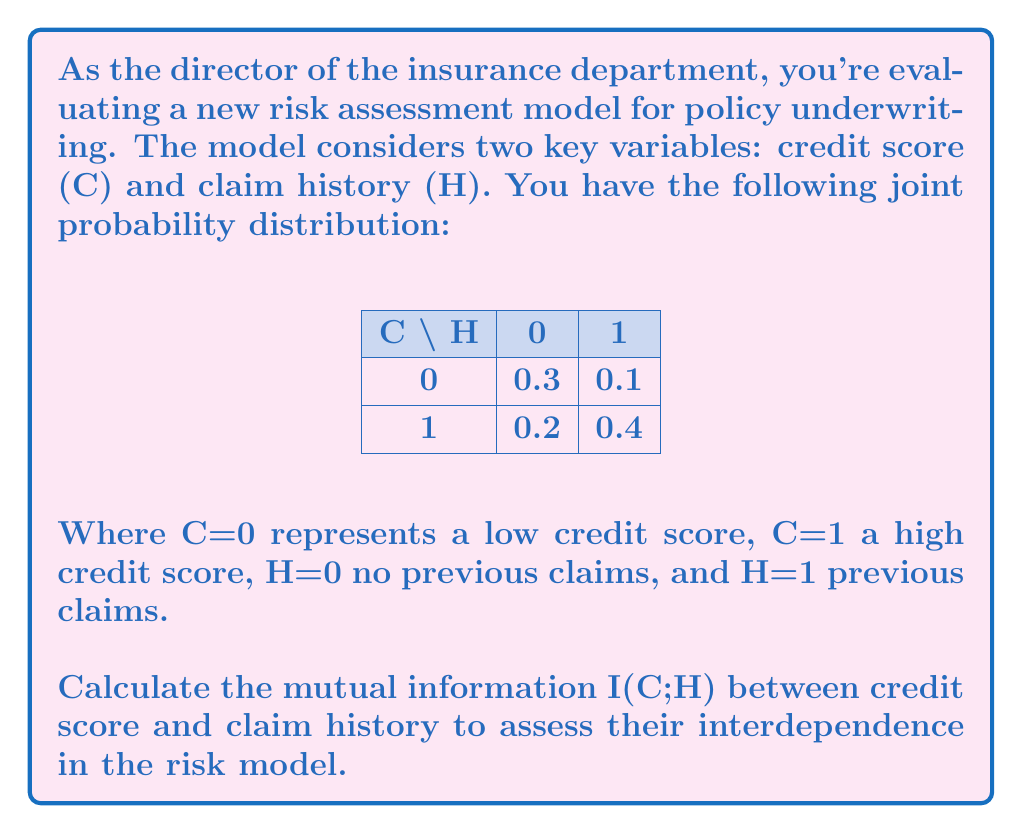Provide a solution to this math problem. To calculate the mutual information I(C;H), we'll follow these steps:

1) First, calculate the marginal probabilities:
   P(C=0) = 0.3 + 0.1 = 0.4
   P(C=1) = 0.2 + 0.4 = 0.6
   P(H=0) = 0.3 + 0.2 = 0.5
   P(H=1) = 0.1 + 0.4 = 0.5

2) The mutual information is given by:
   $$I(C;H) = \sum_{c}\sum_{h} P(c,h) \log_2 \frac{P(c,h)}{P(c)P(h)}$$

3) Let's calculate each term:

   For C=0, H=0: $0.3 \log_2 \frac{0.3}{0.4 \cdot 0.5} = 0.3 \log_2 1.5 = 0.1368$
   For C=0, H=1: $0.1 \log_2 \frac{0.1}{0.4 \cdot 0.5} = 0.1 \log_2 0.5 = -0.1$
   For C=1, H=0: $0.2 \log_2 \frac{0.2}{0.6 \cdot 0.5} = 0.2 \log_2 \frac{2}{3} = -0.0899$
   For C=1, H=1: $0.4 \log_2 \frac{0.4}{0.6 \cdot 0.5} = 0.4 \log_2 \frac{4}{3} = 0.1510$

4) Sum all these terms:
   I(C;H) = 0.1368 + (-0.1) + (-0.0899) + 0.1510 = 0.0979 bits

This value indicates the amount of information shared between credit score and claim history in your risk assessment model.
Answer: 0.0979 bits 